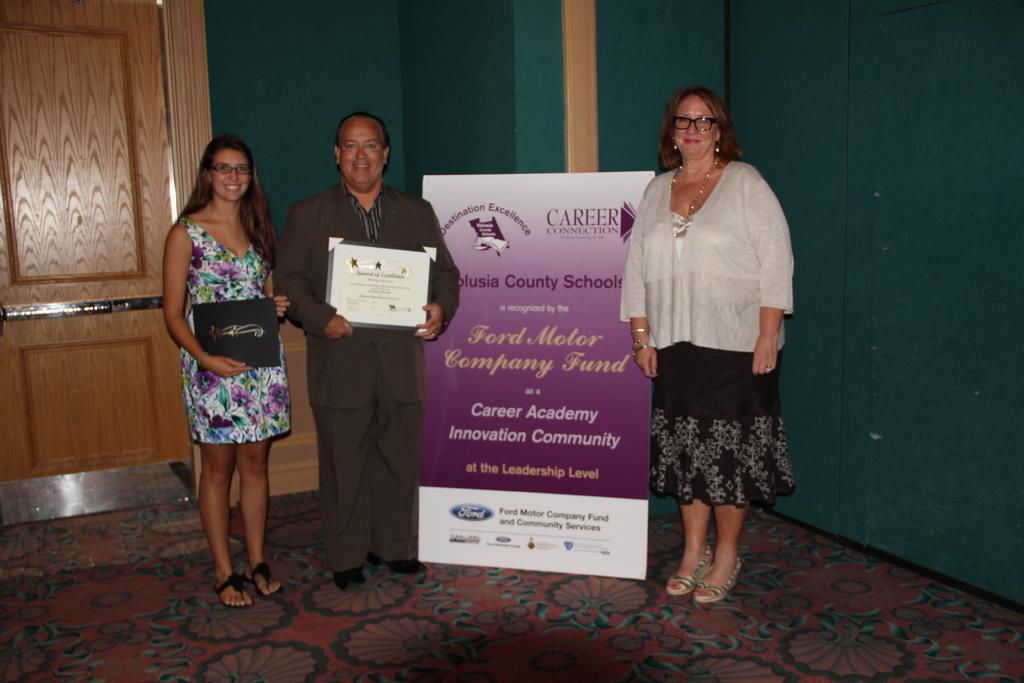Can you describe this image briefly? In the center of the image there are three persons standing. There is a banner. In the background of the image there is a green color wall. To the left side of the image there is a door. At the bottom of the image there is carpet. 